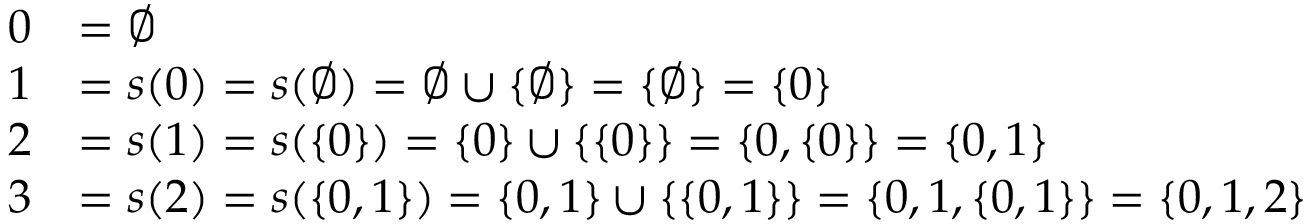Convert formula to latex. <formula><loc_0><loc_0><loc_500><loc_500>{ \begin{array} { r l } { 0 } & { = \emptyset } \\ { 1 } & { = s ( 0 ) = s ( \emptyset ) = \emptyset \cup \{ \emptyset \} = \{ \emptyset \} = \{ 0 \} } \\ { 2 } & { = s ( 1 ) = s ( \{ 0 \} ) = \{ 0 \} \cup \{ \{ 0 \} \} = \{ 0 , \{ 0 \} \} = \{ 0 , 1 \} } \\ { 3 } & { = s ( 2 ) = s ( \{ 0 , 1 \} ) = \{ 0 , 1 \} \cup \{ \{ 0 , 1 \} \} = \{ 0 , 1 , \{ 0 , 1 \} \} = \{ 0 , 1 , 2 \} } \end{array} }</formula> 